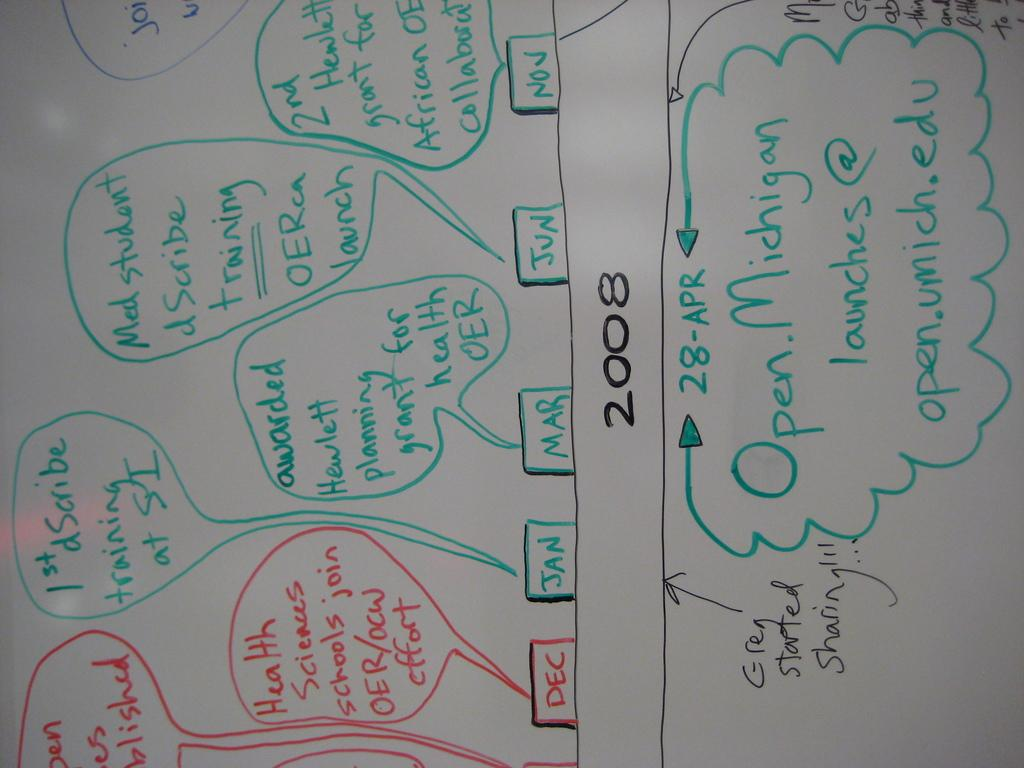<image>
Relay a brief, clear account of the picture shown. A whiteboard with a 2008 schedule for Open Michigan launches. 